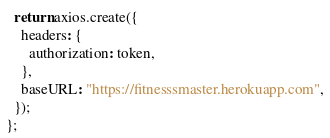<code> <loc_0><loc_0><loc_500><loc_500><_JavaScript_>  return axios.create({
    headers: {
      authorization: token,
    },
    baseURL: "https://fitnesssmaster.herokuapp.com",
  });
};
</code> 